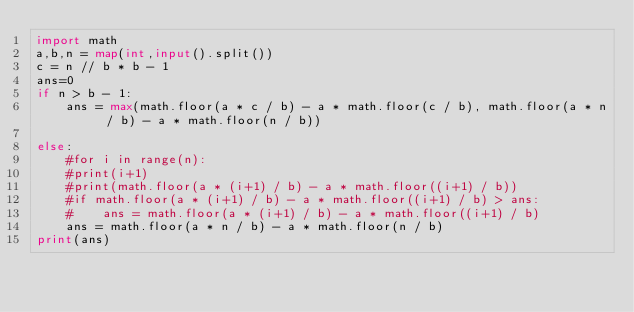<code> <loc_0><loc_0><loc_500><loc_500><_Python_>import math
a,b,n = map(int,input().split())
c = n // b * b - 1
ans=0
if n > b - 1:
    ans = max(math.floor(a * c / b) - a * math.floor(c / b), math.floor(a * n / b) - a * math.floor(n / b))

else:
    #for i in range(n):
    #print(i+1)
    #print(math.floor(a * (i+1) / b) - a * math.floor((i+1) / b))
    #if math.floor(a * (i+1) / b) - a * math.floor((i+1) / b) > ans:
    #    ans = math.floor(a * (i+1) / b) - a * math.floor((i+1) / b)
    ans = math.floor(a * n / b) - a * math.floor(n / b)
print(ans)</code> 